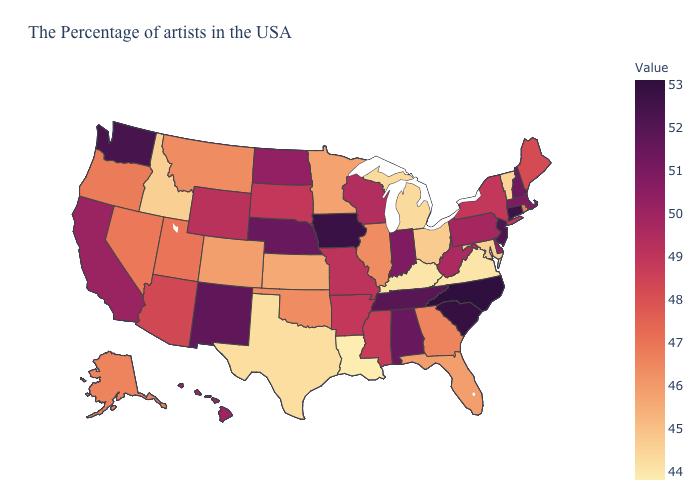Does South Carolina have a lower value than Louisiana?
Concise answer only. No. Does Vermont have the lowest value in the Northeast?
Answer briefly. Yes. Which states have the lowest value in the USA?
Be succinct. Louisiana. Which states have the lowest value in the USA?
Answer briefly. Louisiana. Which states have the lowest value in the West?
Give a very brief answer. Idaho. 